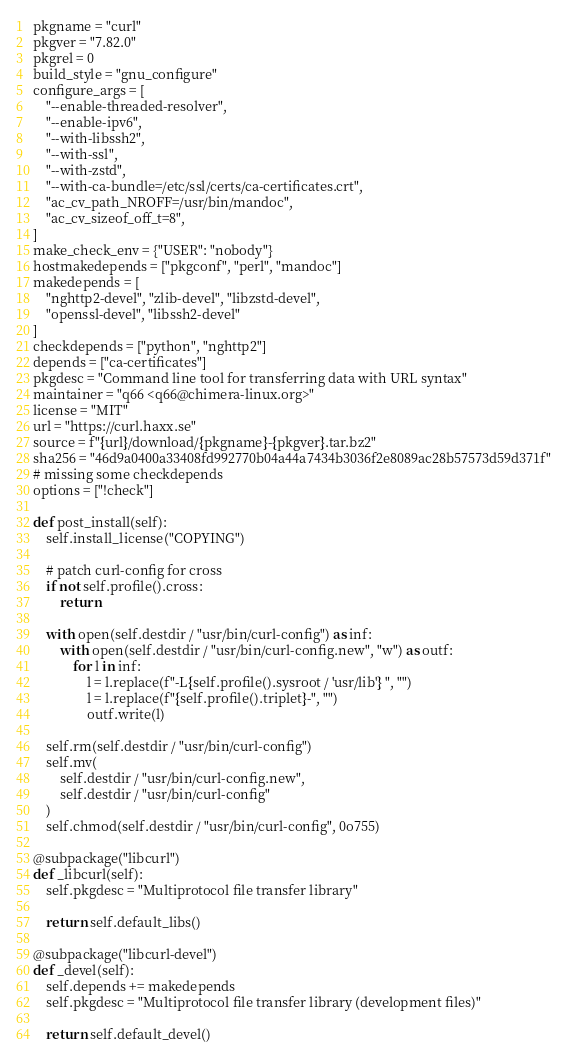Convert code to text. <code><loc_0><loc_0><loc_500><loc_500><_Python_>pkgname = "curl"
pkgver = "7.82.0"
pkgrel = 0
build_style = "gnu_configure"
configure_args = [
    "--enable-threaded-resolver",
    "--enable-ipv6",
    "--with-libssh2",
    "--with-ssl",
    "--with-zstd",
    "--with-ca-bundle=/etc/ssl/certs/ca-certificates.crt",
    "ac_cv_path_NROFF=/usr/bin/mandoc",
    "ac_cv_sizeof_off_t=8",
]
make_check_env = {"USER": "nobody"}
hostmakedepends = ["pkgconf", "perl", "mandoc"]
makedepends = [
    "nghttp2-devel", "zlib-devel", "libzstd-devel",
    "openssl-devel", "libssh2-devel"
]
checkdepends = ["python", "nghttp2"]
depends = ["ca-certificates"]
pkgdesc = "Command line tool for transferring data with URL syntax"
maintainer = "q66 <q66@chimera-linux.org>"
license = "MIT"
url = "https://curl.haxx.se"
source = f"{url}/download/{pkgname}-{pkgver}.tar.bz2"
sha256 = "46d9a0400a33408fd992770b04a44a7434b3036f2e8089ac28b57573d59d371f"
# missing some checkdepends
options = ["!check"]

def post_install(self):
    self.install_license("COPYING")

    # patch curl-config for cross
    if not self.profile().cross:
        return

    with open(self.destdir / "usr/bin/curl-config") as inf:
        with open(self.destdir / "usr/bin/curl-config.new", "w") as outf:
            for l in inf:
                l = l.replace(f"-L{self.profile().sysroot / 'usr/lib'} ", "")
                l = l.replace(f"{self.profile().triplet}-", "")
                outf.write(l)

    self.rm(self.destdir / "usr/bin/curl-config")
    self.mv(
        self.destdir / "usr/bin/curl-config.new",
        self.destdir / "usr/bin/curl-config"
    )
    self.chmod(self.destdir / "usr/bin/curl-config", 0o755)

@subpackage("libcurl")
def _libcurl(self):
    self.pkgdesc = "Multiprotocol file transfer library"

    return self.default_libs()

@subpackage("libcurl-devel")
def _devel(self):
    self.depends += makedepends
    self.pkgdesc = "Multiprotocol file transfer library (development files)"

    return self.default_devel()
</code> 